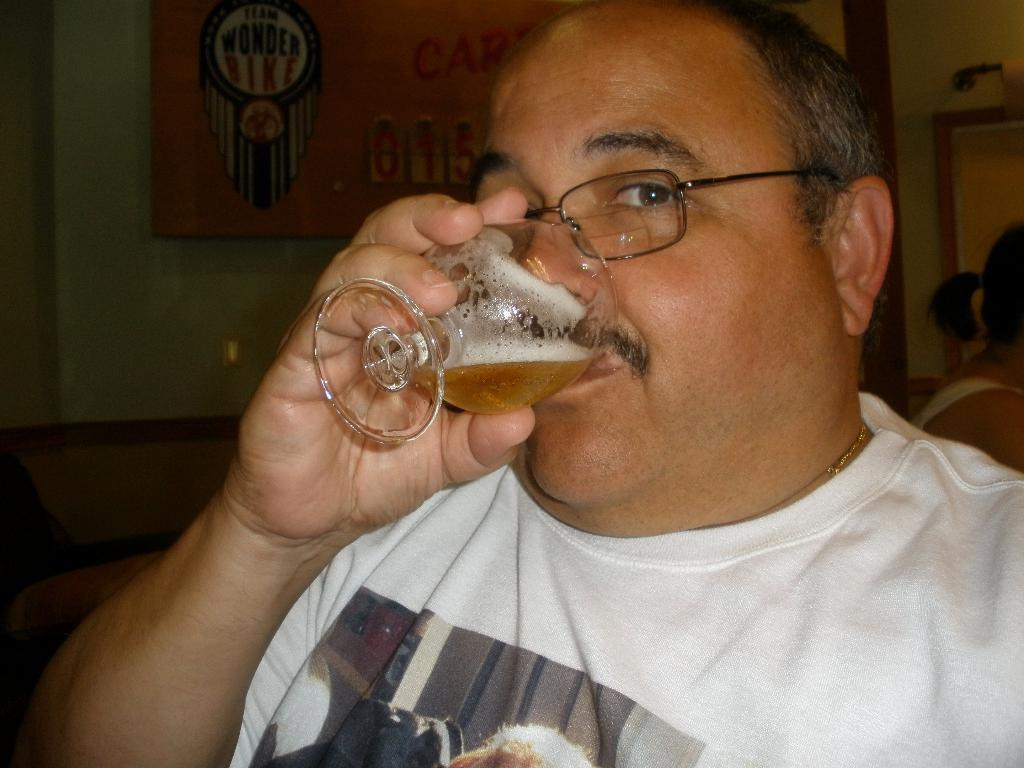What is the main subject of the image? There is a man in the image. What is the man wearing on his upper body? The man is wearing a white T-shirt. What is the man doing in the image? The man is drinking from a glass. What accessory is the man wearing on his face? The man is wearing spectacles. What can be seen in the background of the image? There is a wall in the background of the image. What type of sweater is the man wearing in the image? The man is not wearing a sweater in the image; he is wearing a white T-shirt. What frame is the man standing in front of in the image? There is no frame present in the image; the man is standing in front of a wall. 